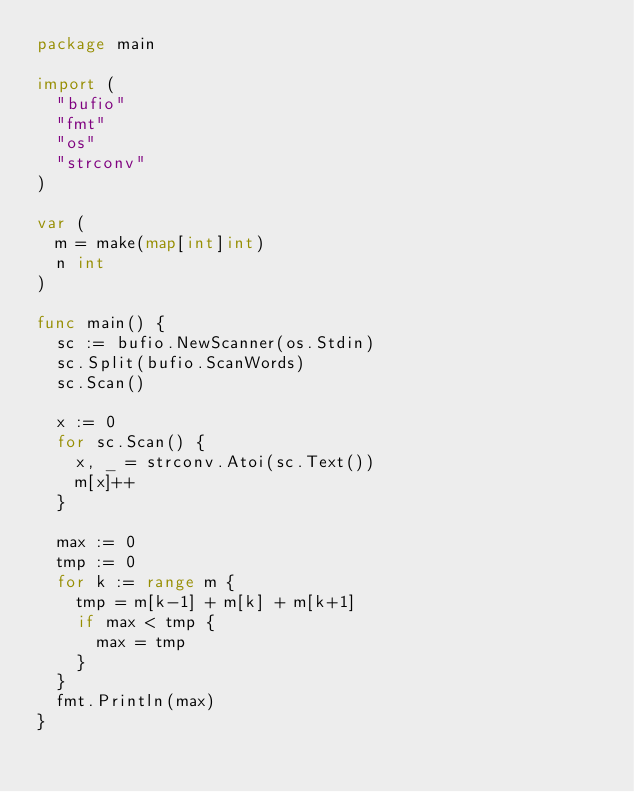Convert code to text. <code><loc_0><loc_0><loc_500><loc_500><_Go_>package main

import (
	"bufio"
	"fmt"
	"os"
	"strconv"
)

var (
	m = make(map[int]int)
	n int
)

func main() {
	sc := bufio.NewScanner(os.Stdin)
	sc.Split(bufio.ScanWords)
	sc.Scan()

	x := 0
	for sc.Scan() {
		x, _ = strconv.Atoi(sc.Text())
		m[x]++
	}

	max := 0
	tmp := 0
	for k := range m {
		tmp = m[k-1] + m[k] + m[k+1]
		if max < tmp {
			max = tmp
		}
	}
	fmt.Println(max)
}
</code> 